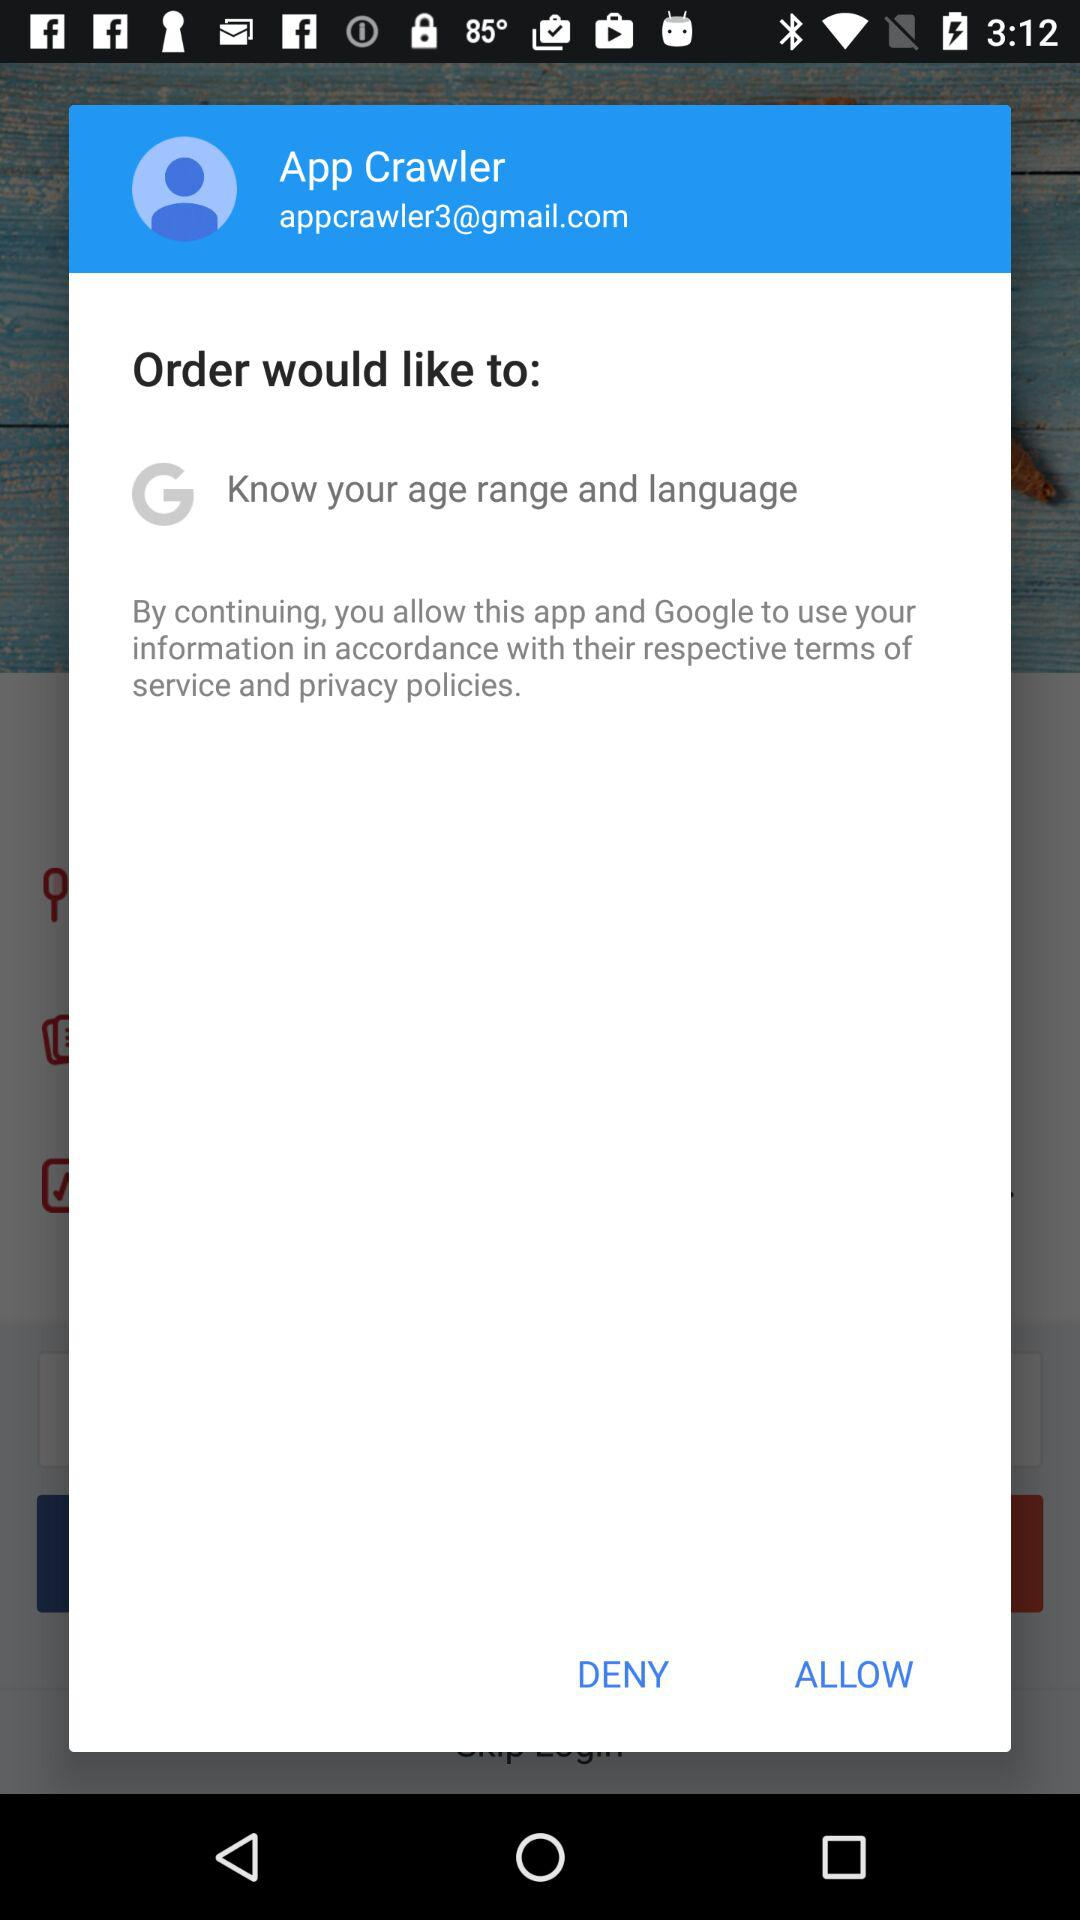What information would Order want? The order would like to know your age range and language. 